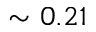<formula> <loc_0><loc_0><loc_500><loc_500>\sim 0 . 2 1</formula> 